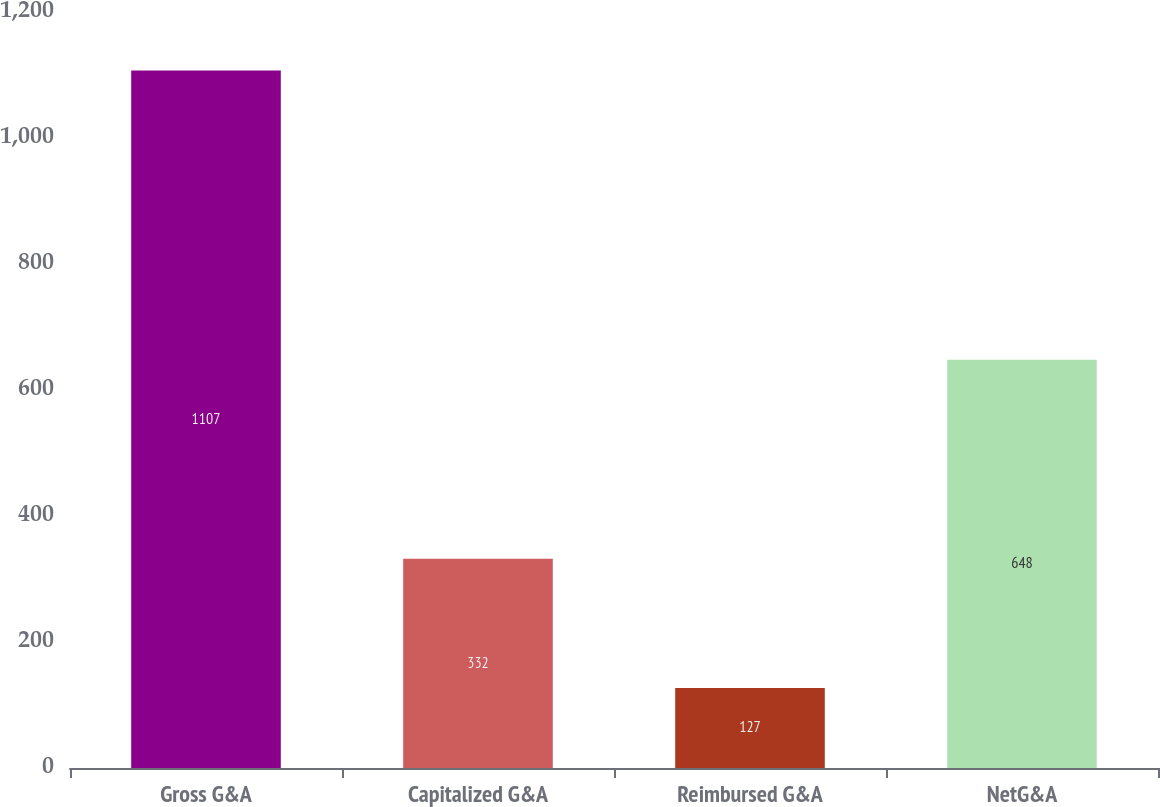Convert chart. <chart><loc_0><loc_0><loc_500><loc_500><bar_chart><fcel>Gross G&A<fcel>Capitalized G&A<fcel>Reimbursed G&A<fcel>NetG&A<nl><fcel>1107<fcel>332<fcel>127<fcel>648<nl></chart> 